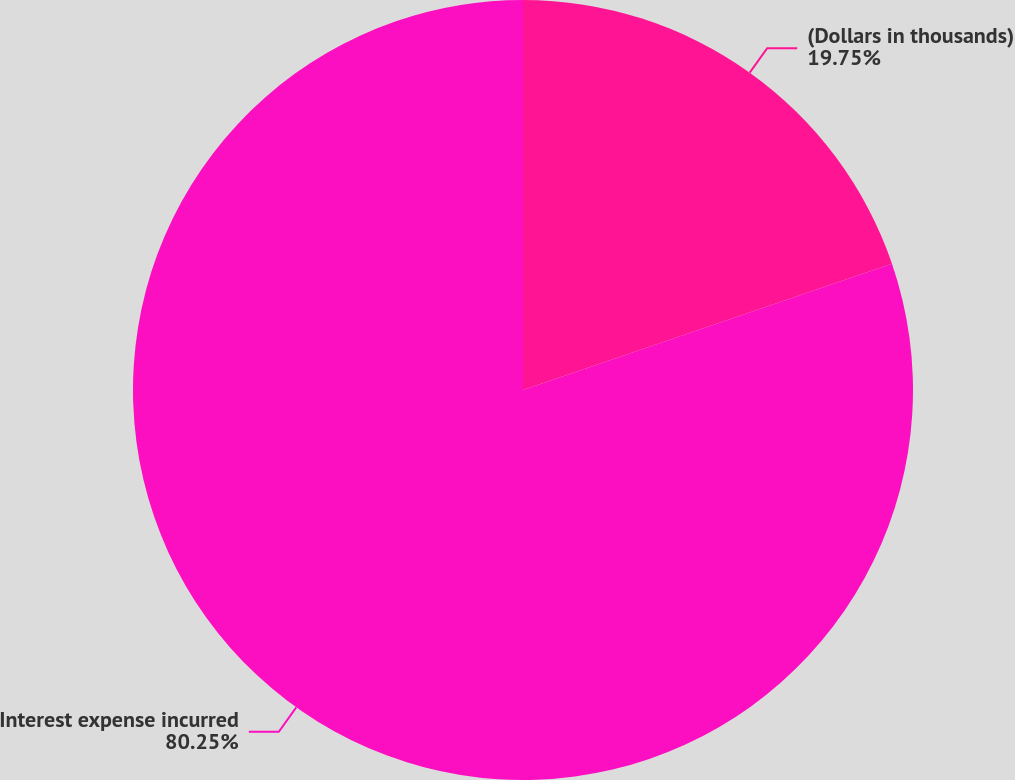<chart> <loc_0><loc_0><loc_500><loc_500><pie_chart><fcel>(Dollars in thousands)<fcel>Interest expense incurred<nl><fcel>19.75%<fcel>80.25%<nl></chart> 